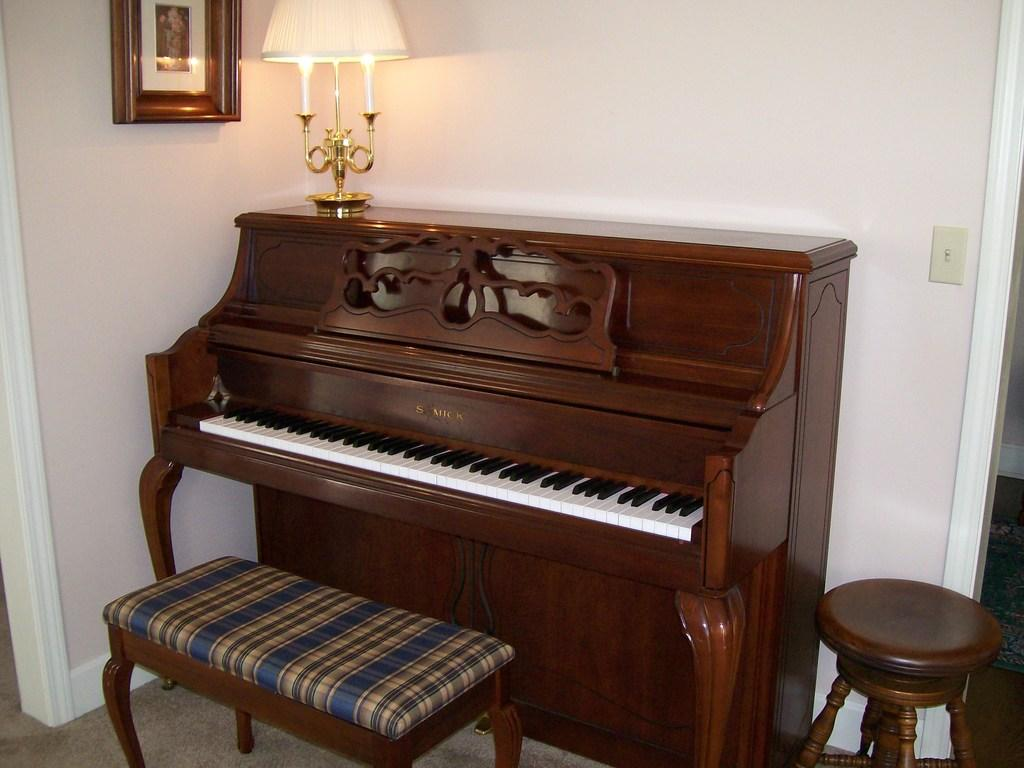What type of musical instrument is in the image? There is a wooden piano in the image. What is the color of the piano? The piano is brown in color. What is placed on top of the piano? There is a lamp on the piano. How many chairs are near the piano? There are two chairs in front and beside the piano. What color is the background wall? The background wall is white in color. What type of toy is sitting on the piano in the image? There is no toy present on the piano in the image. What songs are being played on the piano in the image? The image does not show anyone playing the piano, so it is not possible to determine which songs might be played. 